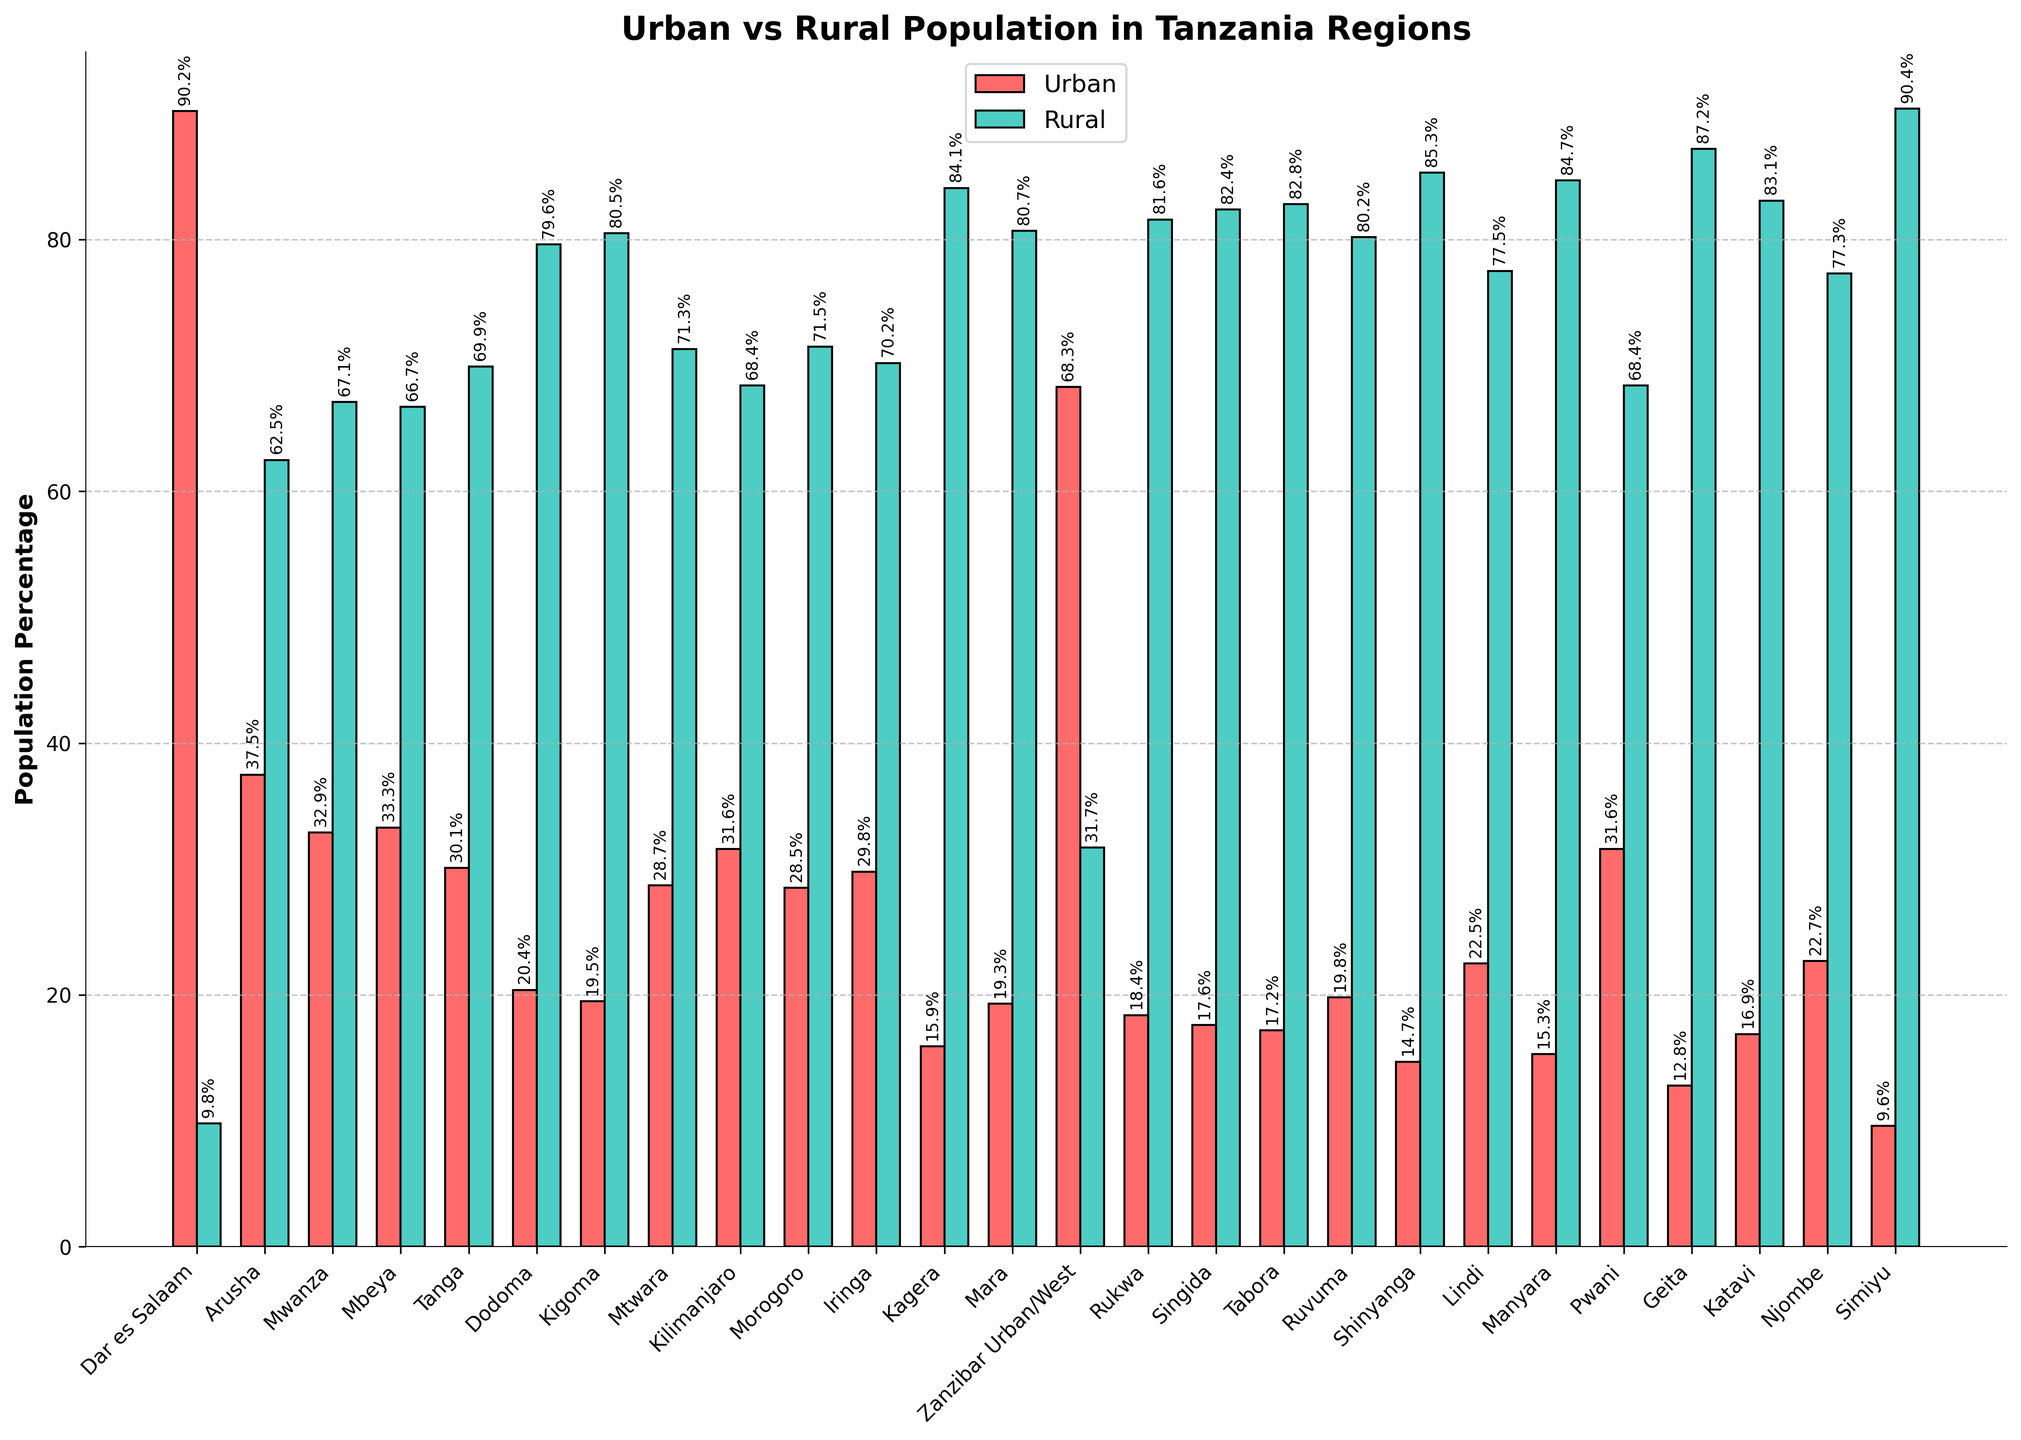Which region has the highest urban population percentage? Look at the bar heights for the 'Urban' population. The highest value is for Dar es Salaam.
Answer: Dar es Salaam Which region has the highest rural population percentage? Look at the bar heights for the 'Rural' population. The highest value is for Simiyu.
Answer: Simiyu What is the total percentage of the urban population for Arusha, Dar es Salaam, and Mwanza combined? Sum the urban percentages of Arusha (37.5), Dar es Salaam (90.2), and Mwanza (32.9). 37.5 + 90.2 + 32.9 = 160.6
Answer: 160.6 Is the rural population percentage in Tanga greater than in Iringa? Compare the heights of the 'Rural' bars for Tanga and Iringa. Tanga has a rural percentage of 69.9, while Iringa has 70.2.
Answer: No Which region has a closer balance between urban and rural populations? The region with almost equal bar heights for both urban and rural populations is Zanzibar Urban/West, with 68.3% urban and 31.7% rural.
Answer: Zanzibar Urban/West What is the average urban population percentage across all regions? Sum all urban percentages and divide by the number of regions. (90.2 + 37.5 + 32.9 + 33.3 + 30.1 + 20.4 + 19.5 + 28.7 + 31.6 + 28.5 + 29.8 + 15.9 + 19.3 + 68.3 + 18.4 + 17.6 + 17.2 + 19.8 + 14.7 + 22.5 + 15.3 + 31.6 + 12.8 + 16.9 + 22.7 + 9.6) / 26 = 26.38
Answer: 26.38 Which regions have an urban population percentage less than 20%? Identify the bars with urban percentages below 20%. Regions: Kagera (15.9), Kigoma (19.5), Mara (19.3), Rukwa (18.4), Singida (17.6), Tabora (17.2), Shinyanga (14.7), Manyara (15.3), Geita (12.8), Katavi (16.9), Simiyu (9.6).
Answer: Kagera, Kigoma, Mara, Rukwa, Singida, Tabora, Shinyanga, Manyara, Geita, Katavi, Simiyu 